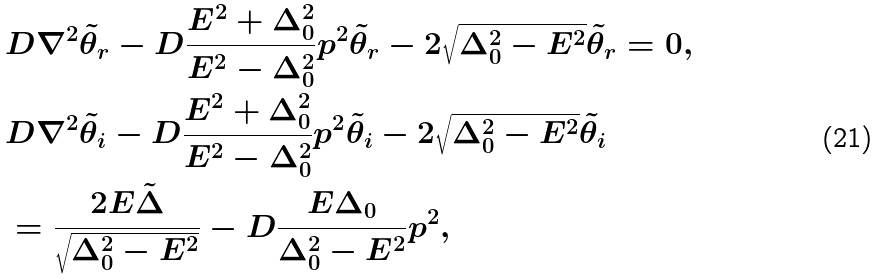Convert formula to latex. <formula><loc_0><loc_0><loc_500><loc_500>& D \nabla ^ { 2 } \tilde { \theta } _ { r } - D \frac { E ^ { 2 } + \Delta _ { 0 } ^ { 2 } } { E ^ { 2 } - \Delta _ { 0 } ^ { 2 } } p ^ { 2 } \tilde { \theta } _ { r } - 2 \sqrt { \Delta _ { 0 } ^ { 2 } - E ^ { 2 } } \tilde { \theta } _ { r } = 0 , \\ & D \nabla ^ { 2 } \tilde { \theta } _ { i } - D \frac { E ^ { 2 } + \Delta _ { 0 } ^ { 2 } } { E ^ { 2 } - \Delta _ { 0 } ^ { 2 } } p ^ { 2 } \tilde { \theta } _ { i } - 2 \sqrt { \Delta _ { 0 } ^ { 2 } - E ^ { 2 } } \tilde { \theta } _ { i } \\ & = \frac { 2 E \tilde { \Delta } } { \sqrt { \Delta _ { 0 } ^ { 2 } - E ^ { 2 } } } - D \frac { E \Delta _ { 0 } } { \Delta _ { 0 } ^ { 2 } - E ^ { 2 } } p ^ { 2 } ,</formula> 